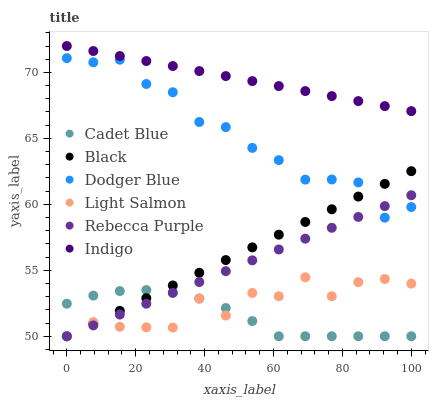Does Cadet Blue have the minimum area under the curve?
Answer yes or no. Yes. Does Indigo have the maximum area under the curve?
Answer yes or no. Yes. Does Indigo have the minimum area under the curve?
Answer yes or no. No. Does Cadet Blue have the maximum area under the curve?
Answer yes or no. No. Is Rebecca Purple the smoothest?
Answer yes or no. Yes. Is Light Salmon the roughest?
Answer yes or no. Yes. Is Cadet Blue the smoothest?
Answer yes or no. No. Is Cadet Blue the roughest?
Answer yes or no. No. Does Light Salmon have the lowest value?
Answer yes or no. Yes. Does Indigo have the lowest value?
Answer yes or no. No. Does Indigo have the highest value?
Answer yes or no. Yes. Does Cadet Blue have the highest value?
Answer yes or no. No. Is Light Salmon less than Indigo?
Answer yes or no. Yes. Is Indigo greater than Rebecca Purple?
Answer yes or no. Yes. Does Light Salmon intersect Black?
Answer yes or no. Yes. Is Light Salmon less than Black?
Answer yes or no. No. Is Light Salmon greater than Black?
Answer yes or no. No. Does Light Salmon intersect Indigo?
Answer yes or no. No. 